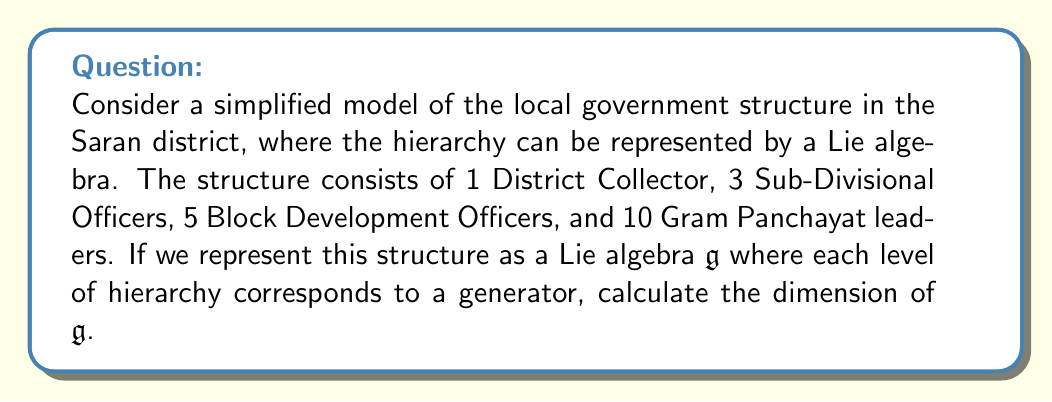Give your solution to this math problem. To calculate the dimension of the Lie algebra $\mathfrak{g}$ representing the local government structure, we need to determine the number of independent generators in the algebra. In this case, each level of the hierarchy contributes to the dimension of the algebra.

Let's break down the structure:

1. District Collector: 1 position (top level)
2. Sub-Divisional Officers: 3 positions
3. Block Development Officers: 5 positions
4. Gram Panchayat leaders: 10 positions

In a Lie algebra representation of this hierarchical structure, each level corresponds to a generator. The number of distinct levels determines the dimension of the algebra, not the number of positions within each level.

Therefore, we have 4 distinct levels in the hierarchy, each contributing one generator to the Lie algebra:

1. $X_1$: generator corresponding to the District Collector level
2. $X_2$: generator corresponding to the Sub-Divisional Officers level
3. $X_3$: generator corresponding to the Block Development Officers level
4. $X_4$: generator corresponding to the Gram Panchayat leaders level

The dimension of a Lie algebra is equal to the number of its generators. In this case, we have 4 generators, so the dimension of $\mathfrak{g}$ is 4.

Mathematically, we can express this as:

$$\dim(\mathfrak{g}) = \text{number of distinct hierarchical levels} = 4$$

It's worth noting that this simplified model assumes that each level in the hierarchy contributes equally to the algebra's structure. In a more complex representation, we might consider additional factors such as the relationships between different levels or the internal structure within each level.
Answer: The dimension of the Lie algebra $\mathfrak{g}$ representing the local government structure is 4. 